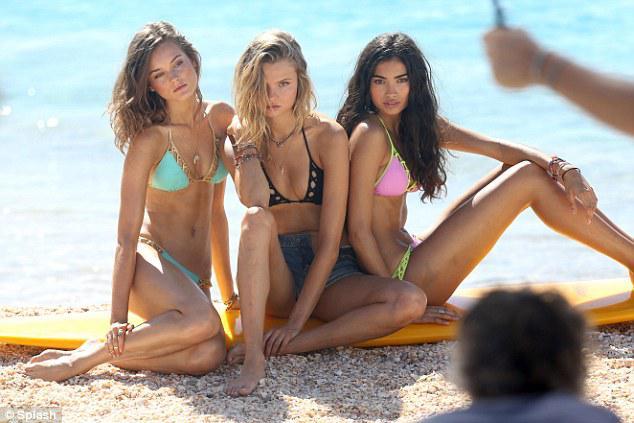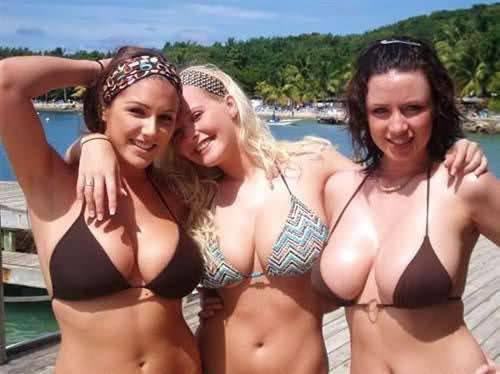The first image is the image on the left, the second image is the image on the right. For the images displayed, is the sentence "There are three girls posing together in bikinis in the right image." factually correct? Answer yes or no. Yes. The first image is the image on the left, the second image is the image on the right. Analyze the images presented: Is the assertion "The right image has three women standing outside." valid? Answer yes or no. Yes. 